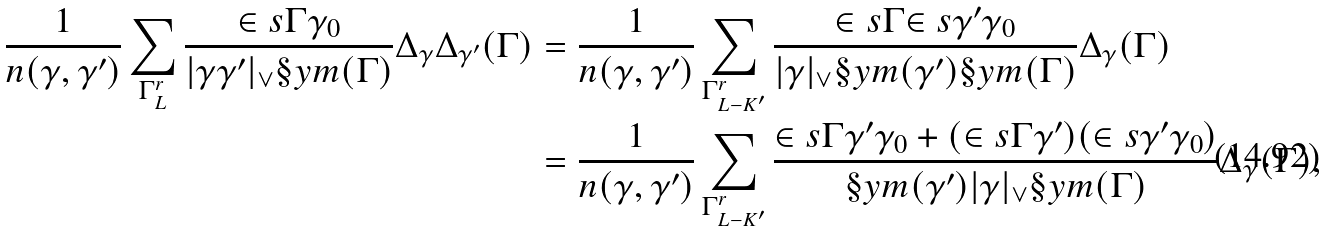Convert formula to latex. <formula><loc_0><loc_0><loc_500><loc_500>\frac { 1 } { n ( \gamma , \gamma ^ { \prime } ) } \sum _ { \Gamma _ { L } ^ { r } } \frac { \in s { \Gamma } { \gamma _ { 0 } } } { | \gamma \gamma ^ { \prime } | _ { \vee } \S y m ( \Gamma ) } \Delta _ { \gamma } \Delta _ { \gamma ^ { \prime } } ( \Gamma ) & = \frac { 1 } { n ( \gamma , \gamma ^ { \prime } ) } \sum _ { \Gamma _ { L - K ^ { \prime } } ^ { r } } \frac { \in s { \Gamma } { \in s { \gamma ^ { \prime } } { \gamma _ { 0 } } } } { | \gamma | _ { \vee } \S y m ( \gamma ^ { \prime } ) \S y m ( \Gamma ) } \Delta _ { \gamma } ( \Gamma ) \\ & = \frac { 1 } { n ( \gamma , \gamma ^ { \prime } ) } \sum _ { \Gamma _ { L - K ^ { \prime } } ^ { r } } \frac { \in s { \Gamma } { \gamma ^ { \prime } \gamma _ { 0 } } + ( \in s { \Gamma } { \gamma ^ { \prime } } ) ( \in s { \gamma ^ { \prime } } { \gamma _ { 0 } } ) } { \S y m ( \gamma ^ { \prime } ) | \gamma | _ { \vee } \S y m ( \Gamma ) } \Delta _ { \gamma } ( \Gamma ) ,</formula> 